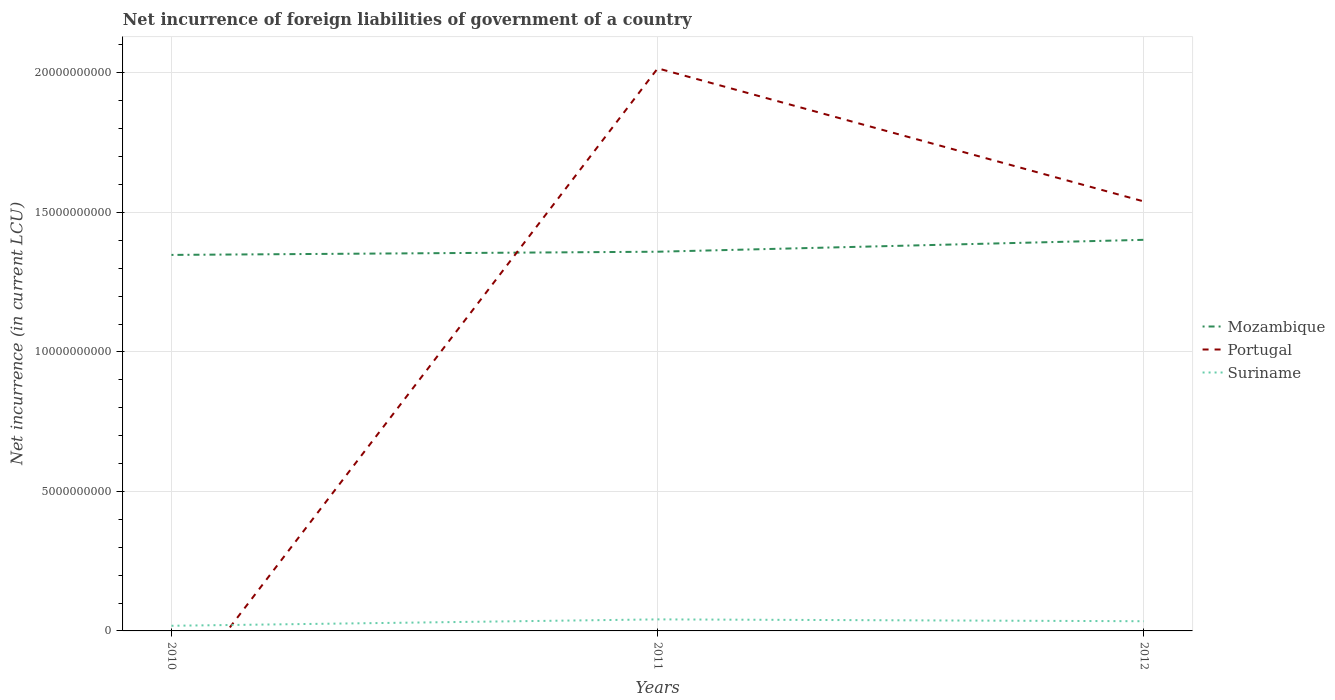How many different coloured lines are there?
Ensure brevity in your answer.  3. Does the line corresponding to Suriname intersect with the line corresponding to Portugal?
Offer a terse response. Yes. Is the number of lines equal to the number of legend labels?
Ensure brevity in your answer.  No. What is the total net incurrence of foreign liabilities in Suriname in the graph?
Ensure brevity in your answer.  -2.29e+08. What is the difference between the highest and the second highest net incurrence of foreign liabilities in Portugal?
Keep it short and to the point. 2.02e+1. What is the difference between the highest and the lowest net incurrence of foreign liabilities in Suriname?
Make the answer very short. 2. Is the net incurrence of foreign liabilities in Portugal strictly greater than the net incurrence of foreign liabilities in Mozambique over the years?
Offer a terse response. No. What is the difference between two consecutive major ticks on the Y-axis?
Provide a succinct answer. 5.00e+09. What is the title of the graph?
Provide a succinct answer. Net incurrence of foreign liabilities of government of a country. What is the label or title of the X-axis?
Your answer should be compact. Years. What is the label or title of the Y-axis?
Provide a succinct answer. Net incurrence (in current LCU). What is the Net incurrence (in current LCU) of Mozambique in 2010?
Your answer should be compact. 1.35e+1. What is the Net incurrence (in current LCU) of Suriname in 2010?
Your response must be concise. 1.84e+08. What is the Net incurrence (in current LCU) of Mozambique in 2011?
Provide a short and direct response. 1.36e+1. What is the Net incurrence (in current LCU) of Portugal in 2011?
Provide a short and direct response. 2.02e+1. What is the Net incurrence (in current LCU) in Suriname in 2011?
Offer a terse response. 4.14e+08. What is the Net incurrence (in current LCU) in Mozambique in 2012?
Offer a very short reply. 1.40e+1. What is the Net incurrence (in current LCU) in Portugal in 2012?
Give a very brief answer. 1.54e+1. What is the Net incurrence (in current LCU) of Suriname in 2012?
Make the answer very short. 3.48e+08. Across all years, what is the maximum Net incurrence (in current LCU) in Mozambique?
Provide a succinct answer. 1.40e+1. Across all years, what is the maximum Net incurrence (in current LCU) of Portugal?
Your answer should be compact. 2.02e+1. Across all years, what is the maximum Net incurrence (in current LCU) of Suriname?
Make the answer very short. 4.14e+08. Across all years, what is the minimum Net incurrence (in current LCU) in Mozambique?
Your answer should be very brief. 1.35e+1. Across all years, what is the minimum Net incurrence (in current LCU) in Suriname?
Make the answer very short. 1.84e+08. What is the total Net incurrence (in current LCU) of Mozambique in the graph?
Your response must be concise. 4.11e+1. What is the total Net incurrence (in current LCU) of Portugal in the graph?
Make the answer very short. 3.56e+1. What is the total Net incurrence (in current LCU) in Suriname in the graph?
Provide a short and direct response. 9.46e+08. What is the difference between the Net incurrence (in current LCU) of Mozambique in 2010 and that in 2011?
Offer a terse response. -1.14e+08. What is the difference between the Net incurrence (in current LCU) in Suriname in 2010 and that in 2011?
Make the answer very short. -2.29e+08. What is the difference between the Net incurrence (in current LCU) of Mozambique in 2010 and that in 2012?
Provide a succinct answer. -5.41e+08. What is the difference between the Net incurrence (in current LCU) in Suriname in 2010 and that in 2012?
Your response must be concise. -1.63e+08. What is the difference between the Net incurrence (in current LCU) in Mozambique in 2011 and that in 2012?
Ensure brevity in your answer.  -4.27e+08. What is the difference between the Net incurrence (in current LCU) of Portugal in 2011 and that in 2012?
Your answer should be compact. 4.77e+09. What is the difference between the Net incurrence (in current LCU) of Suriname in 2011 and that in 2012?
Provide a short and direct response. 6.60e+07. What is the difference between the Net incurrence (in current LCU) of Mozambique in 2010 and the Net incurrence (in current LCU) of Portugal in 2011?
Provide a short and direct response. -6.69e+09. What is the difference between the Net incurrence (in current LCU) of Mozambique in 2010 and the Net incurrence (in current LCU) of Suriname in 2011?
Your answer should be very brief. 1.31e+1. What is the difference between the Net incurrence (in current LCU) in Mozambique in 2010 and the Net incurrence (in current LCU) in Portugal in 2012?
Offer a very short reply. -1.91e+09. What is the difference between the Net incurrence (in current LCU) of Mozambique in 2010 and the Net incurrence (in current LCU) of Suriname in 2012?
Provide a short and direct response. 1.31e+1. What is the difference between the Net incurrence (in current LCU) of Mozambique in 2011 and the Net incurrence (in current LCU) of Portugal in 2012?
Ensure brevity in your answer.  -1.80e+09. What is the difference between the Net incurrence (in current LCU) in Mozambique in 2011 and the Net incurrence (in current LCU) in Suriname in 2012?
Ensure brevity in your answer.  1.32e+1. What is the difference between the Net incurrence (in current LCU) of Portugal in 2011 and the Net incurrence (in current LCU) of Suriname in 2012?
Provide a succinct answer. 1.98e+1. What is the average Net incurrence (in current LCU) in Mozambique per year?
Your answer should be compact. 1.37e+1. What is the average Net incurrence (in current LCU) of Portugal per year?
Your response must be concise. 1.19e+1. What is the average Net incurrence (in current LCU) of Suriname per year?
Make the answer very short. 3.15e+08. In the year 2010, what is the difference between the Net incurrence (in current LCU) of Mozambique and Net incurrence (in current LCU) of Suriname?
Ensure brevity in your answer.  1.33e+1. In the year 2011, what is the difference between the Net incurrence (in current LCU) of Mozambique and Net incurrence (in current LCU) of Portugal?
Make the answer very short. -6.57e+09. In the year 2011, what is the difference between the Net incurrence (in current LCU) of Mozambique and Net incurrence (in current LCU) of Suriname?
Ensure brevity in your answer.  1.32e+1. In the year 2011, what is the difference between the Net incurrence (in current LCU) of Portugal and Net incurrence (in current LCU) of Suriname?
Give a very brief answer. 1.97e+1. In the year 2012, what is the difference between the Net incurrence (in current LCU) of Mozambique and Net incurrence (in current LCU) of Portugal?
Provide a succinct answer. -1.37e+09. In the year 2012, what is the difference between the Net incurrence (in current LCU) of Mozambique and Net incurrence (in current LCU) of Suriname?
Offer a very short reply. 1.37e+1. In the year 2012, what is the difference between the Net incurrence (in current LCU) of Portugal and Net incurrence (in current LCU) of Suriname?
Offer a very short reply. 1.50e+1. What is the ratio of the Net incurrence (in current LCU) in Suriname in 2010 to that in 2011?
Offer a terse response. 0.45. What is the ratio of the Net incurrence (in current LCU) of Mozambique in 2010 to that in 2012?
Keep it short and to the point. 0.96. What is the ratio of the Net incurrence (in current LCU) in Suriname in 2010 to that in 2012?
Make the answer very short. 0.53. What is the ratio of the Net incurrence (in current LCU) in Mozambique in 2011 to that in 2012?
Ensure brevity in your answer.  0.97. What is the ratio of the Net incurrence (in current LCU) in Portugal in 2011 to that in 2012?
Give a very brief answer. 1.31. What is the ratio of the Net incurrence (in current LCU) in Suriname in 2011 to that in 2012?
Your answer should be very brief. 1.19. What is the difference between the highest and the second highest Net incurrence (in current LCU) of Mozambique?
Make the answer very short. 4.27e+08. What is the difference between the highest and the second highest Net incurrence (in current LCU) in Suriname?
Provide a short and direct response. 6.60e+07. What is the difference between the highest and the lowest Net incurrence (in current LCU) in Mozambique?
Keep it short and to the point. 5.41e+08. What is the difference between the highest and the lowest Net incurrence (in current LCU) in Portugal?
Your answer should be compact. 2.02e+1. What is the difference between the highest and the lowest Net incurrence (in current LCU) of Suriname?
Ensure brevity in your answer.  2.29e+08. 